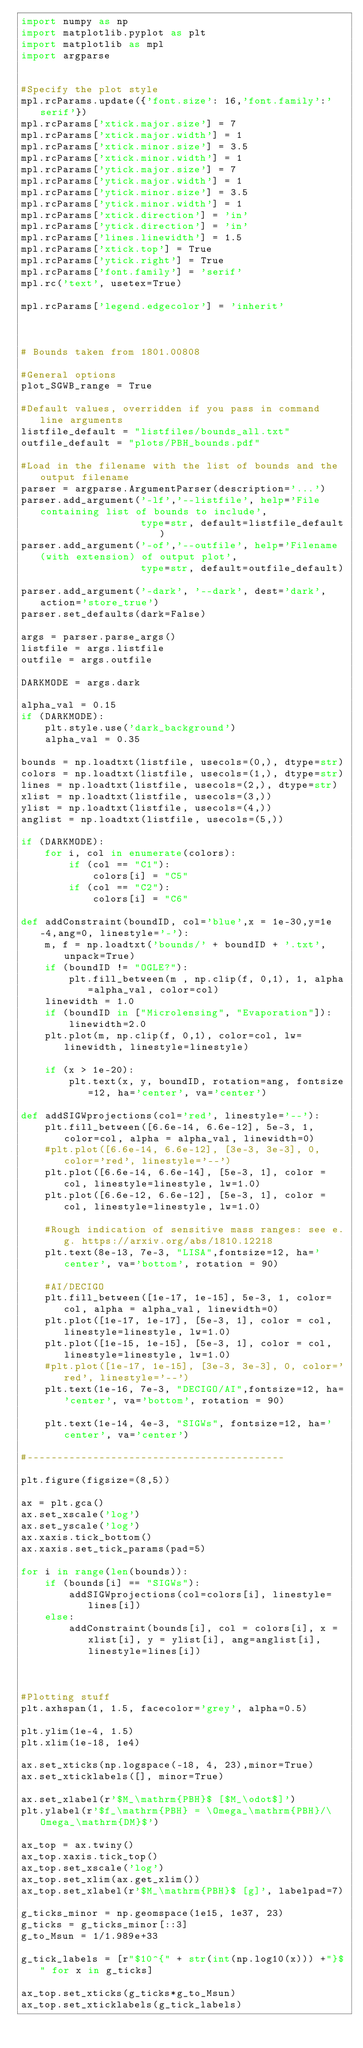Convert code to text. <code><loc_0><loc_0><loc_500><loc_500><_Python_>import numpy as np
import matplotlib.pyplot as plt
import matplotlib as mpl
import argparse


#Specify the plot style
mpl.rcParams.update({'font.size': 16,'font.family':'serif'})
mpl.rcParams['xtick.major.size'] = 7
mpl.rcParams['xtick.major.width'] = 1
mpl.rcParams['xtick.minor.size'] = 3.5
mpl.rcParams['xtick.minor.width'] = 1
mpl.rcParams['ytick.major.size'] = 7
mpl.rcParams['ytick.major.width'] = 1
mpl.rcParams['ytick.minor.size'] = 3.5
mpl.rcParams['ytick.minor.width'] = 1
mpl.rcParams['xtick.direction'] = 'in'
mpl.rcParams['ytick.direction'] = 'in'
mpl.rcParams['lines.linewidth'] = 1.5
mpl.rcParams['xtick.top'] = True
mpl.rcParams['ytick.right'] = True
mpl.rcParams['font.family'] = 'serif'
mpl.rc('text', usetex=True)

mpl.rcParams['legend.edgecolor'] = 'inherit'



# Bounds taken from 1801.00808

#General options
plot_SGWB_range = True

#Default values, overridden if you pass in command line arguments
listfile_default = "listfiles/bounds_all.txt" 
outfile_default = "plots/PBH_bounds.pdf"

#Load in the filename with the list of bounds and the output filename
parser = argparse.ArgumentParser(description='...')
parser.add_argument('-lf','--listfile', help='File containing list of bounds to include',
                    type=str, default=listfile_default)
parser.add_argument('-of','--outfile', help='Filename (with extension) of output plot', 
                    type=str, default=outfile_default)
                    
parser.add_argument('-dark', '--dark', dest='dark', action='store_true')
parser.set_defaults(dark=False)

args = parser.parse_args()
listfile = args.listfile
outfile = args.outfile

DARKMODE = args.dark

alpha_val = 0.15
if (DARKMODE):
    plt.style.use('dark_background')
    alpha_val = 0.35

bounds = np.loadtxt(listfile, usecols=(0,), dtype=str)
colors = np.loadtxt(listfile, usecols=(1,), dtype=str)
lines = np.loadtxt(listfile, usecols=(2,), dtype=str)
xlist = np.loadtxt(listfile, usecols=(3,))
ylist = np.loadtxt(listfile, usecols=(4,))
anglist = np.loadtxt(listfile, usecols=(5,))

if (DARKMODE):
    for i, col in enumerate(colors):
        if (col == "C1"):
            colors[i] = "C5"
        if (col == "C2"):
            colors[i] = "C6"

def addConstraint(boundID, col='blue',x = 1e-30,y=1e-4,ang=0, linestyle='-'):
    m, f = np.loadtxt('bounds/' + boundID + '.txt', unpack=True)
    if (boundID != "OGLE?"):
        plt.fill_between(m , np.clip(f, 0,1), 1, alpha=alpha_val, color=col)
    linewidth = 1.0
    if (boundID in ["Microlensing", "Evaporation"]):
        linewidth=2.0
    plt.plot(m, np.clip(f, 0,1), color=col, lw=linewidth, linestyle=linestyle)
    
    if (x > 1e-20):
        plt.text(x, y, boundID, rotation=ang, fontsize=12, ha='center', va='center')

def addSIGWprojections(col='red', linestyle='--'):
    plt.fill_between([6.6e-14, 6.6e-12], 5e-3, 1, color=col, alpha = alpha_val, linewidth=0)
    #plt.plot([6.6e-14, 6.6e-12], [3e-3, 3e-3], 0, color='red', linestyle='--')
    plt.plot([6.6e-14, 6.6e-14], [5e-3, 1], color = col, linestyle=linestyle, lw=1.0)
    plt.plot([6.6e-12, 6.6e-12], [5e-3, 1], color = col, linestyle=linestyle, lw=1.0)
    
    #Rough indication of sensitive mass ranges: see e.g. https://arxiv.org/abs/1810.12218
    plt.text(8e-13, 7e-3, "LISA",fontsize=12, ha='center', va='bottom', rotation = 90)

    #AI/DECIGO
    plt.fill_between([1e-17, 1e-15], 5e-3, 1, color=col, alpha = alpha_val, linewidth=0)
    plt.plot([1e-17, 1e-17], [5e-3, 1], color = col, linestyle=linestyle, lw=1.0)
    plt.plot([1e-15, 1e-15], [5e-3, 1], color = col, linestyle=linestyle, lw=1.0)
    #plt.plot([1e-17, 1e-15], [3e-3, 3e-3], 0, color='red', linestyle='--')
    plt.text(1e-16, 7e-3, "DECIGO/AI",fontsize=12, ha='center', va='bottom', rotation = 90)
    
    plt.text(1e-14, 4e-3, "SIGWs", fontsize=12, ha='center', va='center')

#-------------------------------------------    
    
plt.figure(figsize=(8,5))

ax = plt.gca()
ax.set_xscale('log')
ax.set_yscale('log')
ax.xaxis.tick_bottom()
ax.xaxis.set_tick_params(pad=5)

for i in range(len(bounds)):  
    if (bounds[i] == "SIGWs"):
        addSIGWprojections(col=colors[i], linestyle=lines[i])
    else:
        addConstraint(bounds[i], col = colors[i], x = xlist[i], y = ylist[i], ang=anglist[i], linestyle=lines[i])



#Plotting stuff
plt.axhspan(1, 1.5, facecolor='grey', alpha=0.5)
    
plt.ylim(1e-4, 1.5)
plt.xlim(1e-18, 1e4)
    
ax.set_xticks(np.logspace(-18, 4, 23),minor=True)
ax.set_xticklabels([], minor=True)
    
ax.set_xlabel(r'$M_\mathrm{PBH}$ [$M_\odot$]')
plt.ylabel(r'$f_\mathrm{PBH} = \Omega_\mathrm{PBH}/\Omega_\mathrm{DM}$')

ax_top = ax.twiny()
ax_top.xaxis.tick_top()
ax_top.set_xscale('log')
ax_top.set_xlim(ax.get_xlim())
ax_top.set_xlabel(r'$M_\mathrm{PBH}$ [g]', labelpad=7)

g_ticks_minor = np.geomspace(1e15, 1e37, 23)
g_ticks = g_ticks_minor[::3]
g_to_Msun = 1/1.989e+33

g_tick_labels = [r"$10^{" + str(int(np.log10(x))) +"}$" for x in g_ticks]

ax_top.set_xticks(g_ticks*g_to_Msun)
ax_top.set_xticklabels(g_tick_labels)</code> 